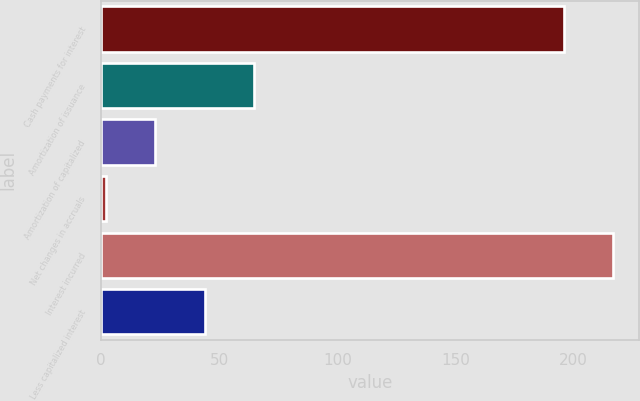<chart> <loc_0><loc_0><loc_500><loc_500><bar_chart><fcel>Cash payments for interest<fcel>Amortization of issuance<fcel>Amortization of capitalized<fcel>Net changes in accruals<fcel>Interest incurred<fcel>Less capitalized interest<nl><fcel>196<fcel>64.7<fcel>22.9<fcel>2<fcel>216.9<fcel>43.8<nl></chart> 